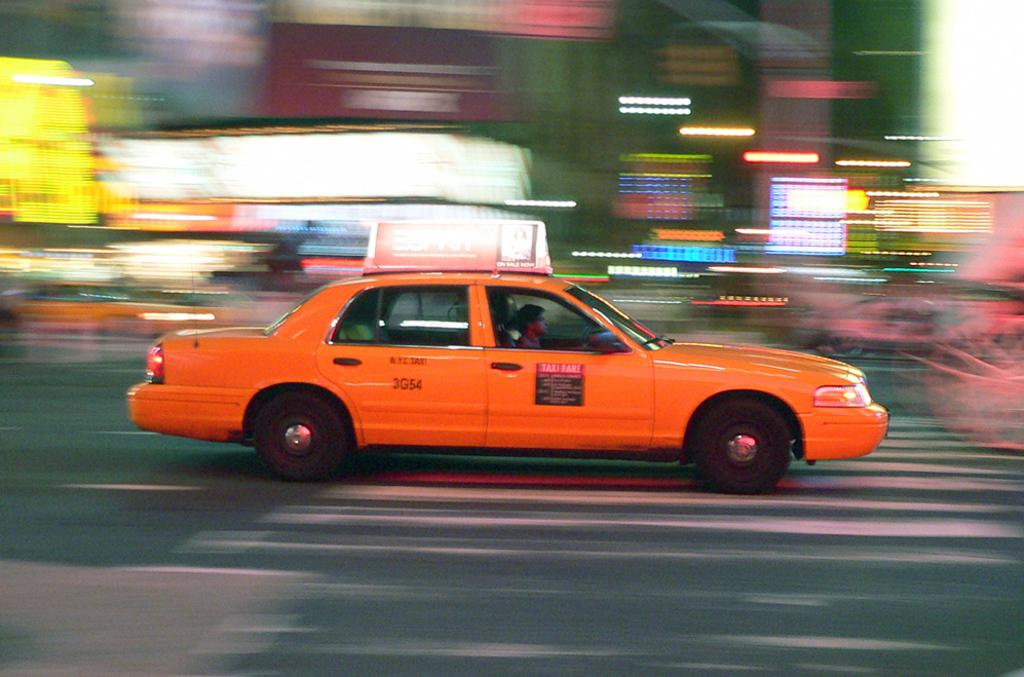<image>
Summarize the visual content of the image. Taxi 3G54 drives as the passing lights streak across the image. 